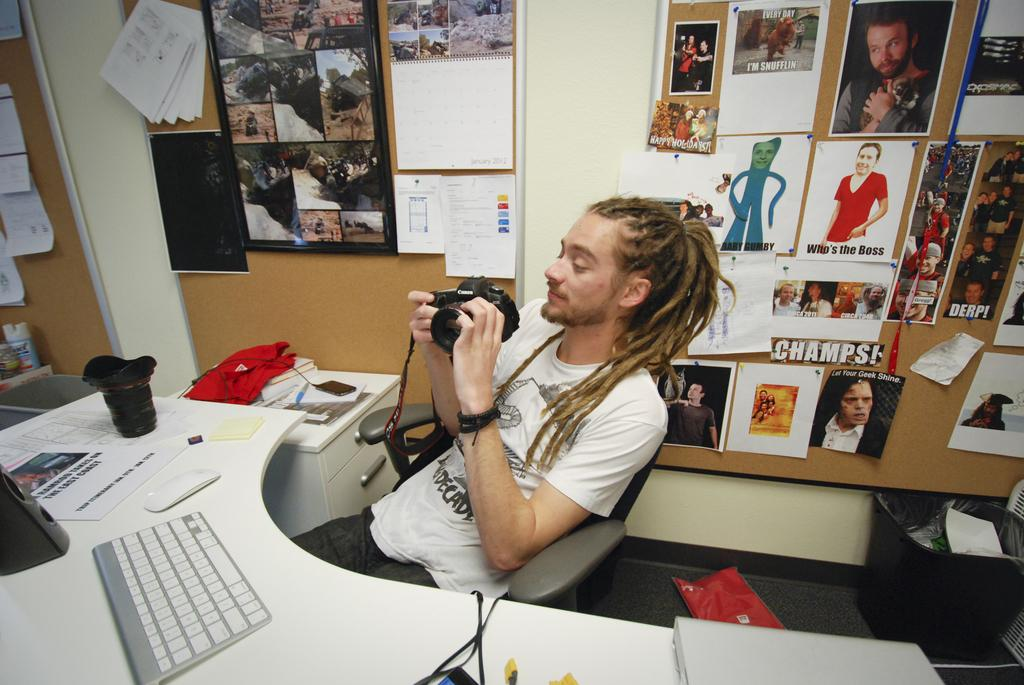What is the man in the image doing? The man is seated in the image and holding a camera in his hand. What object is on the table in the image? There is a computer on a table in the image. What can be seen on the board in the image? There are posters on a board in the image. What type of wilderness can be seen through the window in the image? There is no window or wilderness present in the image. 